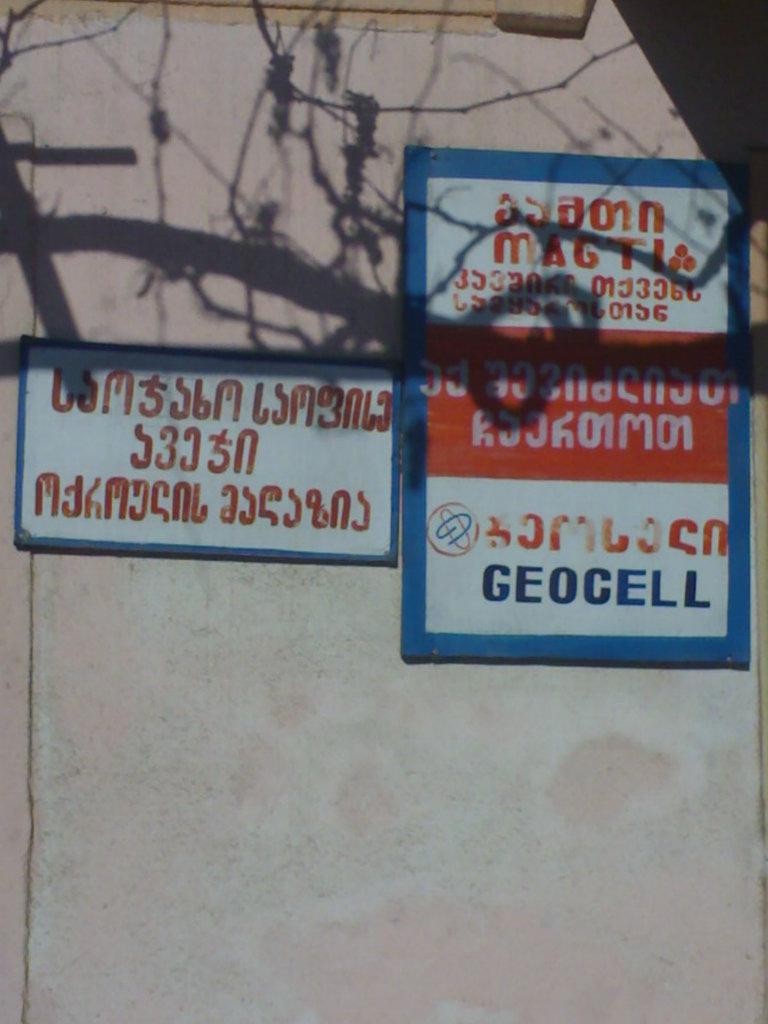Is the right sign about geocell?
Your response must be concise. Yes. What is the sign about?
Make the answer very short. Unanswerable. 